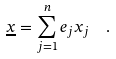Convert formula to latex. <formula><loc_0><loc_0><loc_500><loc_500>\underline { x } = \sum _ { j = 1 } ^ { n } e _ { j } x _ { j } \ \ .</formula> 